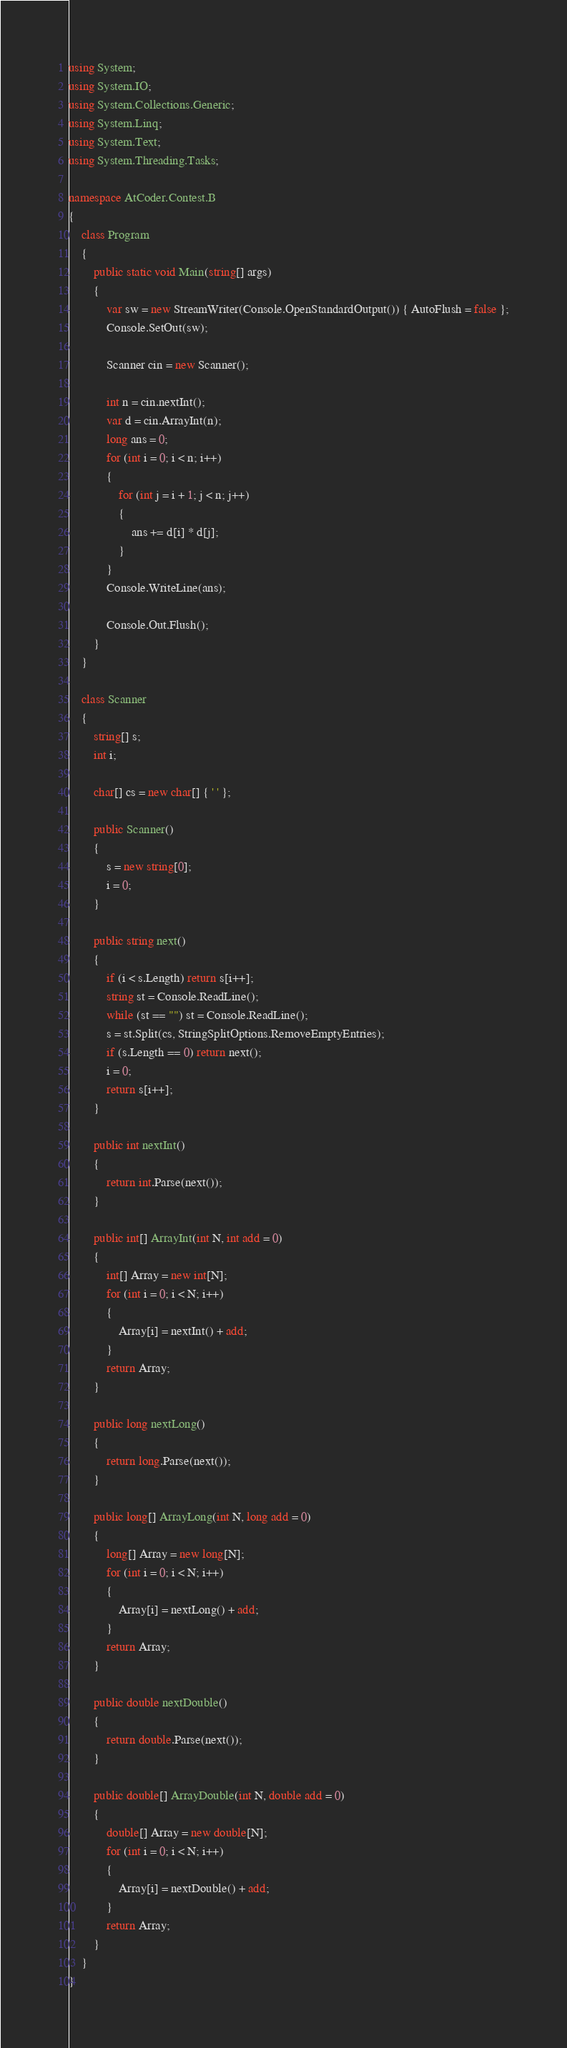<code> <loc_0><loc_0><loc_500><loc_500><_C#_>using System;
using System.IO;
using System.Collections.Generic;
using System.Linq;
using System.Text;
using System.Threading.Tasks;

namespace AtCoder.Contest.B
{
	class Program
	{
		public static void Main(string[] args)
		{
			var sw = new StreamWriter(Console.OpenStandardOutput()) { AutoFlush = false };
			Console.SetOut(sw);

			Scanner cin = new Scanner();

			int n = cin.nextInt();
			var d = cin.ArrayInt(n);
			long ans = 0;
			for (int i = 0; i < n; i++)
			{
				for (int j = i + 1; j < n; j++)
				{
					ans += d[i] * d[j];
				}
			}
			Console.WriteLine(ans);

			Console.Out.Flush();
		}
	}

	class Scanner
	{
		string[] s;
		int i;

		char[] cs = new char[] { ' ' };

		public Scanner()
		{
			s = new string[0];
			i = 0;
		}

		public string next()
		{
			if (i < s.Length) return s[i++];
			string st = Console.ReadLine();
			while (st == "") st = Console.ReadLine();
			s = st.Split(cs, StringSplitOptions.RemoveEmptyEntries);
			if (s.Length == 0) return next();
			i = 0;
			return s[i++];
		}

		public int nextInt()
		{
			return int.Parse(next());
		}

		public int[] ArrayInt(int N, int add = 0)
		{
			int[] Array = new int[N];
			for (int i = 0; i < N; i++)
			{
				Array[i] = nextInt() + add;
			}
			return Array;
		}

		public long nextLong()
		{
			return long.Parse(next());
		}

		public long[] ArrayLong(int N, long add = 0)
		{
			long[] Array = new long[N];
			for (int i = 0; i < N; i++)
			{
				Array[i] = nextLong() + add;
			}
			return Array;
		}

		public double nextDouble()
		{
			return double.Parse(next());
		}

		public double[] ArrayDouble(int N, double add = 0)
		{
			double[] Array = new double[N];
			for (int i = 0; i < N; i++)
			{
				Array[i] = nextDouble() + add;
			}
			return Array;
		}
	}
}</code> 